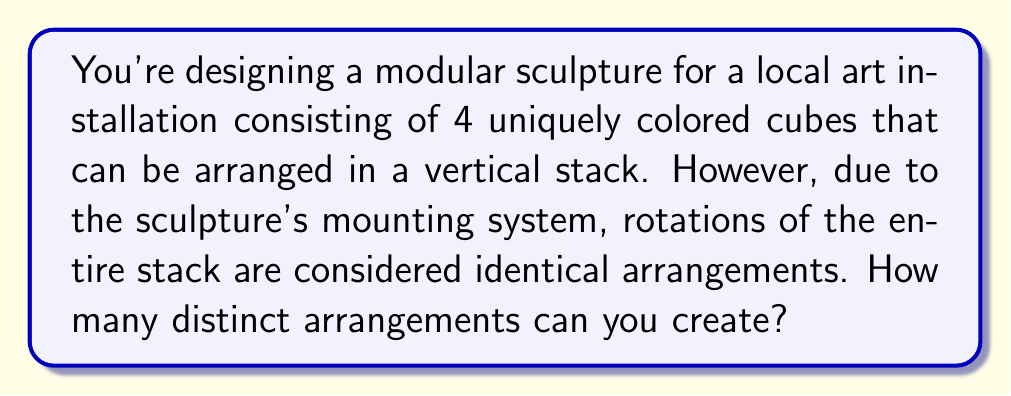Help me with this question. Let's approach this step-by-step:

1) First, without considering rotations, we would have 4! = 24 possible arrangements of the 4 cubes.

2) However, we need to account for rotations. Since these are cubes, each arrangement can be rotated 4 ways (90°, 180°, 270°, and 360°/0°) and still be considered the same arrangement.

3) This means we need to divide our total number of arrangements by 4 to get the number of unique arrangements.

4) Mathematically, we can express this as:

   $$\text{Number of unique arrangements} = \frac{4!}{4} = \frac{24}{4} = 6$$

5) We can confirm this by listing out the 6 unique arrangements:
   - ABCD (also represents BCDA, CDAB, DABC)
   - ABDC (also represents BDCA, DCAB, CABD)
   - ACBD (also represents CBDA, BDAC, DACB)
   - ACDB (also represents CDBA, DBAC, BACD)
   - ADBC (also represents DBCA, BCAD, CADB)
   - ADCB (also represents DCBA, CBAD, BADC)

   Where A, B, C, and D represent the four different colored cubes.

This problem is an application of the orbit-stabilizer theorem in group theory, where we're considering the action of the cyclic group $C_4$ (representing rotations) on the set of all permutations of 4 objects.
Answer: 6 distinct arrangements 